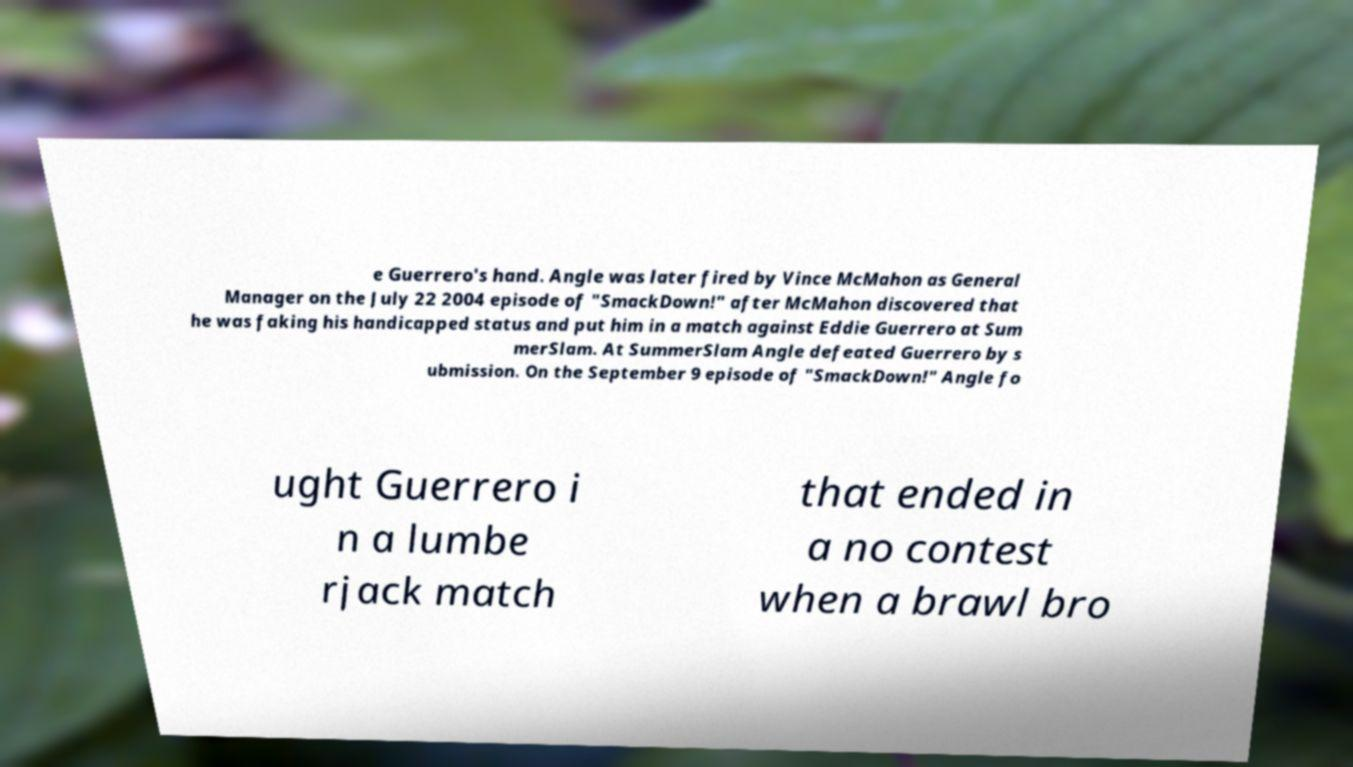I need the written content from this picture converted into text. Can you do that? e Guerrero's hand. Angle was later fired by Vince McMahon as General Manager on the July 22 2004 episode of "SmackDown!" after McMahon discovered that he was faking his handicapped status and put him in a match against Eddie Guerrero at Sum merSlam. At SummerSlam Angle defeated Guerrero by s ubmission. On the September 9 episode of "SmackDown!" Angle fo ught Guerrero i n a lumbe rjack match that ended in a no contest when a brawl bro 